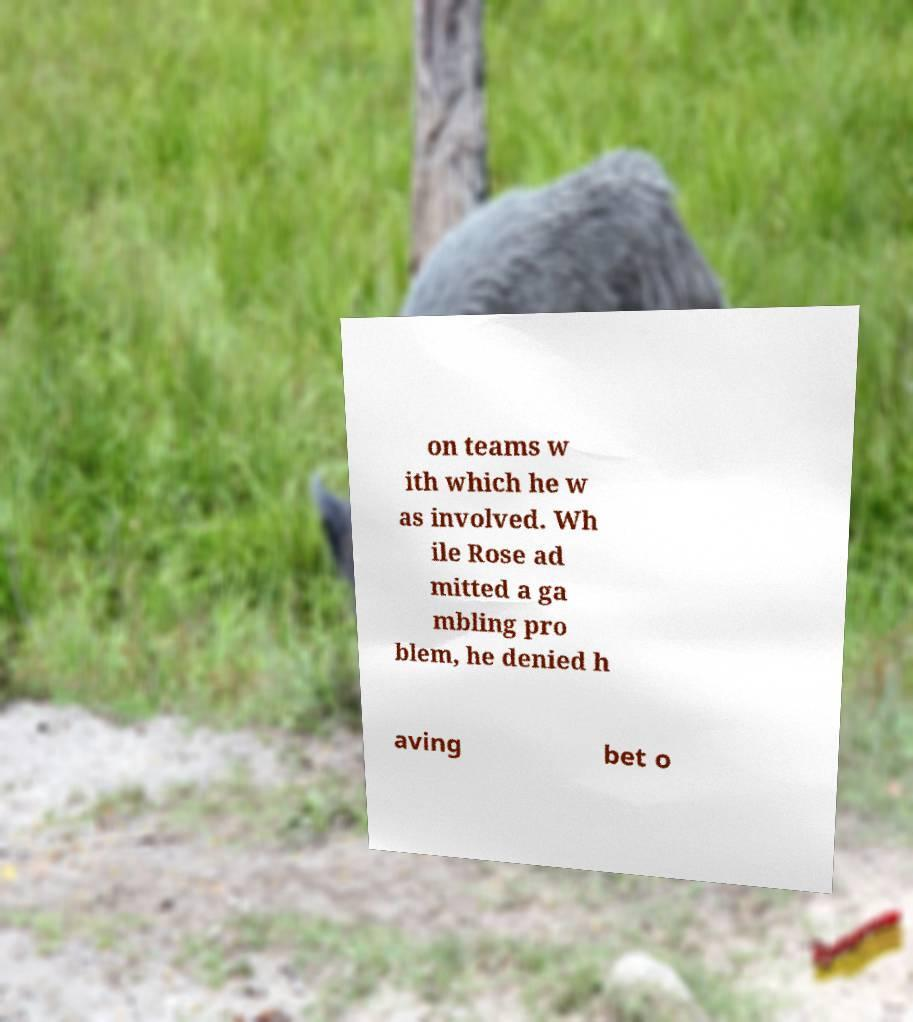Please identify and transcribe the text found in this image. on teams w ith which he w as involved. Wh ile Rose ad mitted a ga mbling pro blem, he denied h aving bet o 